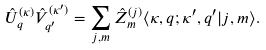<formula> <loc_0><loc_0><loc_500><loc_500>\hat { U } ^ { ( \kappa ) } _ { q } \hat { V } ^ { ( \kappa ^ { \prime } ) } _ { q ^ { \prime } } = \sum _ { j , m } \hat { Z } ^ { ( j ) } _ { m } \langle \kappa , q ; \kappa ^ { \prime } , q ^ { \prime } | j , m \rangle .</formula> 